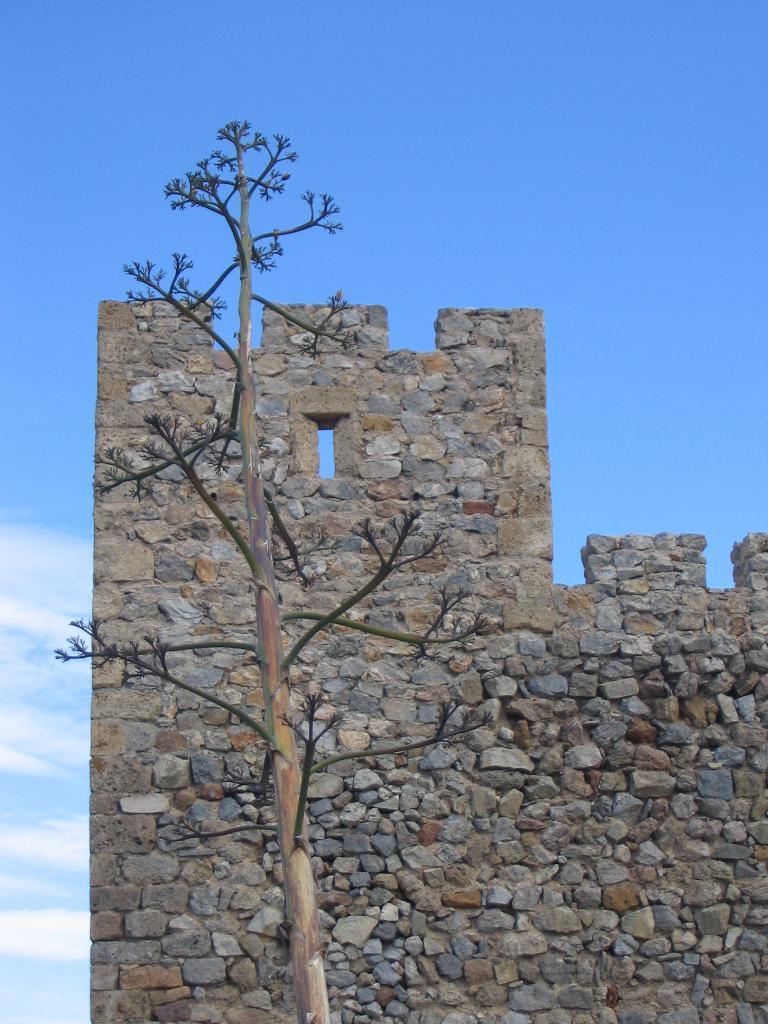Could you give a brief overview of what you see in this image? In this picture I can see a stone wall, a tree and I can see a blue cloudy sky. 